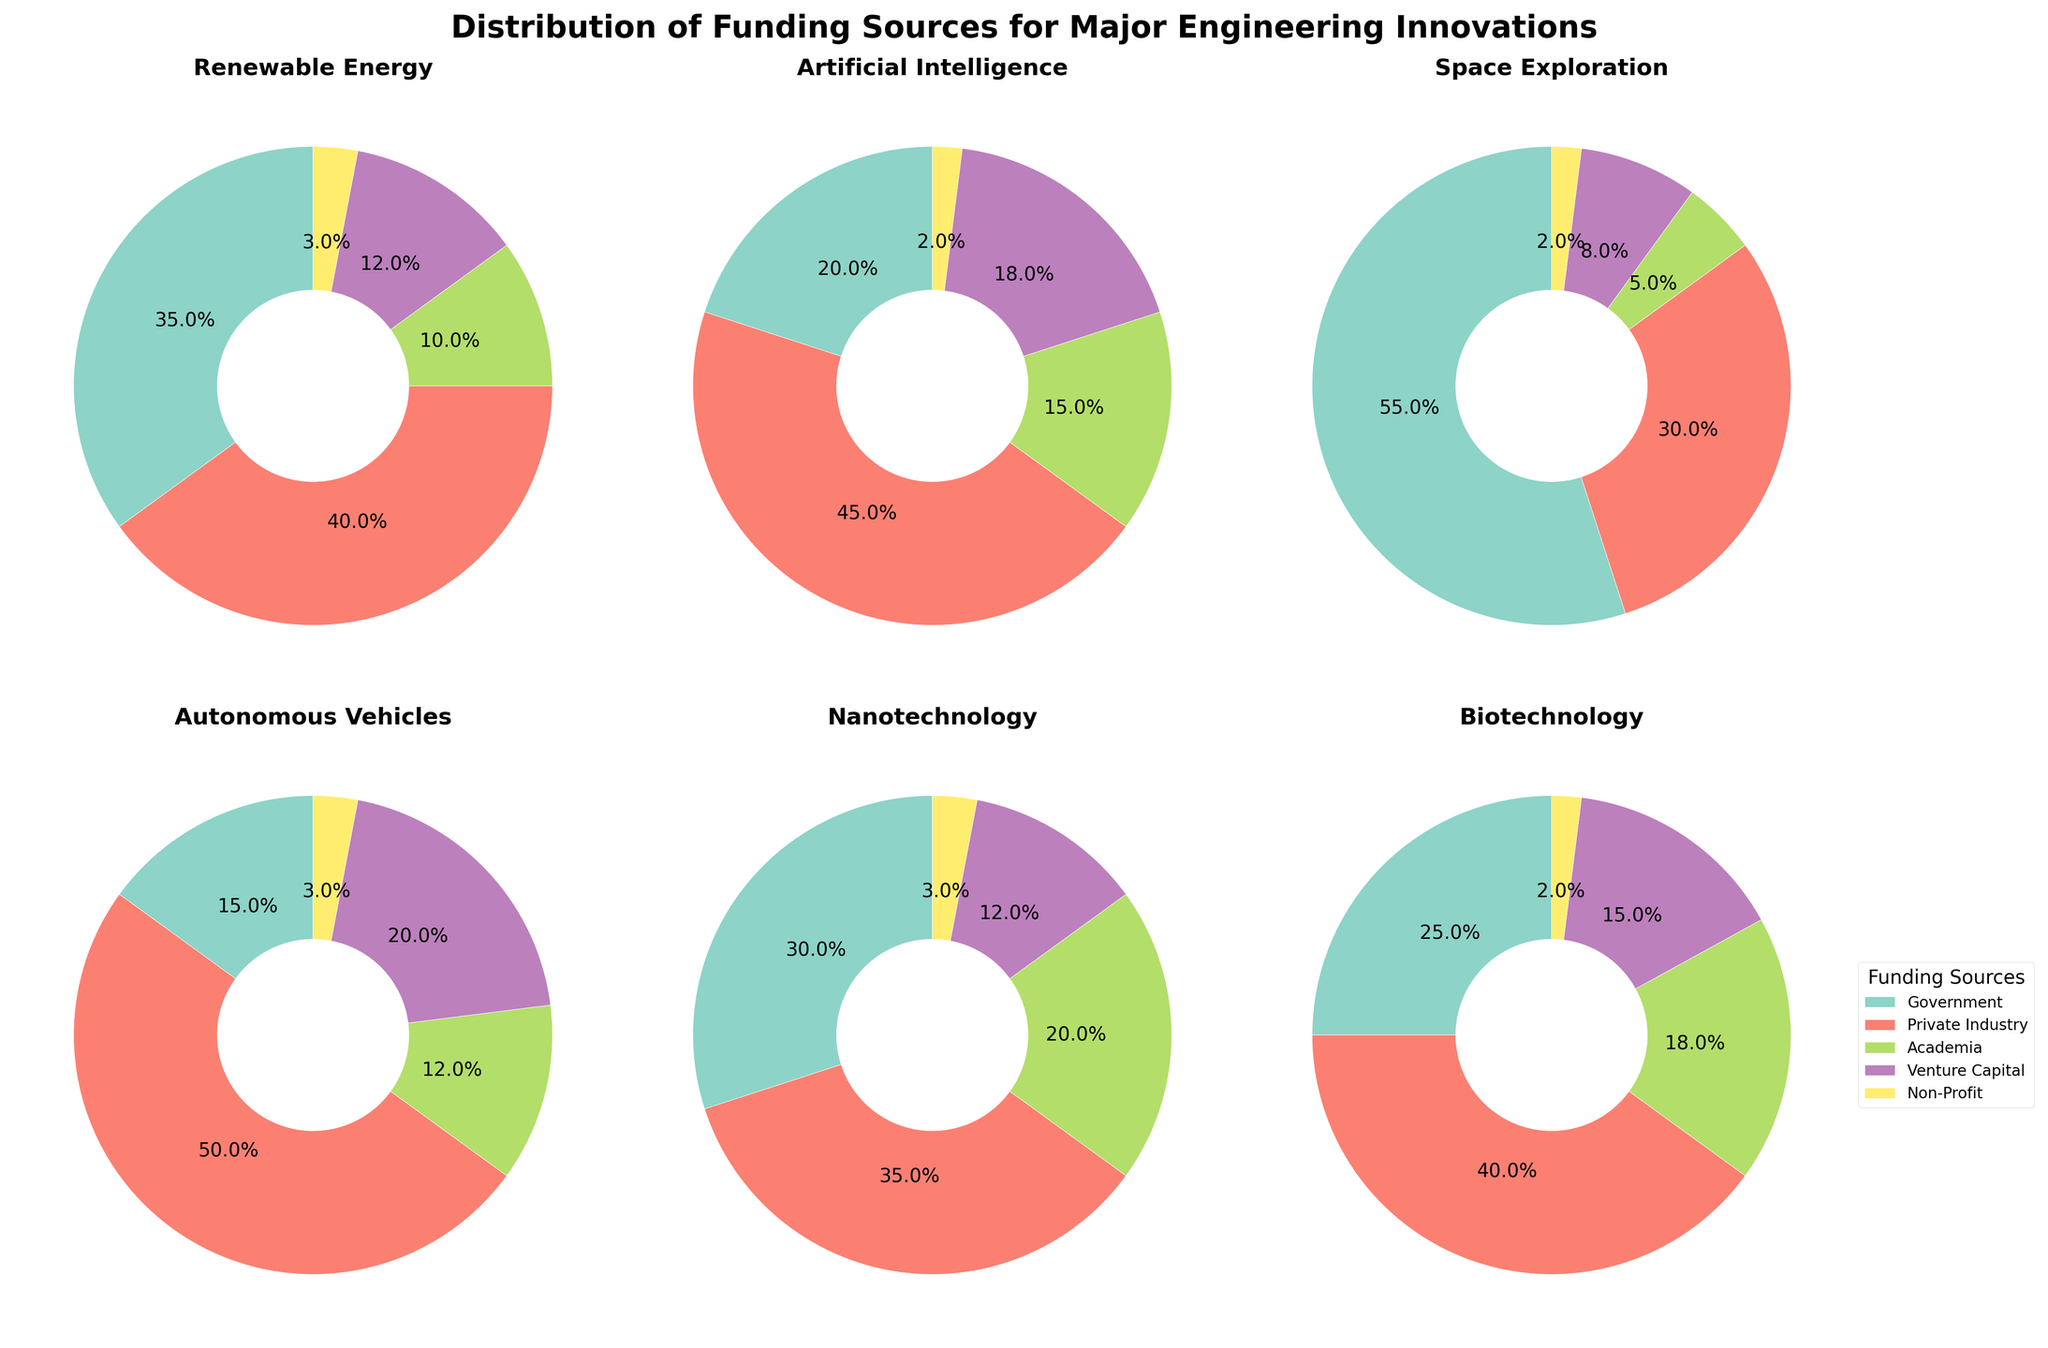What is the title of the overall figure? The title is usually found at the top of the figure, often in larger or bold font. For this specific subplot, the title is indicated above all pie charts.
Answer: Distribution of Funding Sources for Major Engineering Innovations Which innovation has the highest percentage of government funding? To determine this, look at the slice marked for 'Government' in each pie chart and compare their percentages. The pie chart for 'Space Exploration' shows the highest percentage for government funding.
Answer: Space Exploration What is the combined percentage of Academia funding for Nanotechnology and Biotechnology? Identify the percentage of Academia funding from the pie charts for Nanotechnology (20%) and Biotechnology (18%), then sum these percentages: 20% + 18% = 38%.
Answer: 38% Which innovations have the same percentage of Non-Profit funding? Check each pie chart for the Non-Profit funding percentage. 'Renewable Energy', 'Artificial Intelligence', 'Space Exploration', 'Autonomous Vehicles', 'Nanotechnology', and 'Biotechnology' all have 2% Non-Profit funding.
Answer: Artificial Intelligence, Space Exploration, Biotechnology How does the percentage of Private Industry funding for Artificial Intelligence compare to that for Autonomous Vehicles? From the pie charts, Artificial Intelligence has 45% Private Industry funding, while Autonomous Vehicles has 50%. Compare these values to see that Autonomous Vehicles has a higher percentage.
Answer: Autonomous Vehicles > Artificial Intelligence Which funding source consistently receives the lowest percentage across all innovations? Identify the lowest percentage slice for each innovation. Non-Profit funding is consistently the lowest percentage in each pie chart.
Answer: Non-Profit What is the average percentage of Venture Capital funding across all innovations? Sum the Venture Capital percentages: 12% (Renewable Energy) + 18% (Artificial Intelligence) + 8% (Space Exploration) + 20% (Autonomous Vehicles) + 12% (Nanotechnology) + 15% (Biotechnology) = 85%. Then, divide by the number of innovations (6): 85% / 6 ≈ 14.2%.
Answer: 14.2% Which innovation relies most heavily on non-governmental funding sources, and what is their combined percentage? Non-governmental funding sources include Private Industry, Academia, Venture Capital, and Non-Profit. Calculate the sum for each innovation. For Autonomous Vehicles: 50% + 12% + 20% + 3% = 85%, which is the highest among all the innovations.
Answer: Autonomous Vehicles, 85% Which innovation has the greatest disparity between its highest and lowest funding sources, and what is the difference? For each innovation, find the highest and lowest funding source percentages and calculate the difference. Space Exploration has 55% (Government) and 2% (Non-Profit), with a difference of 53%.
Answer: Space Exploration, 53% 